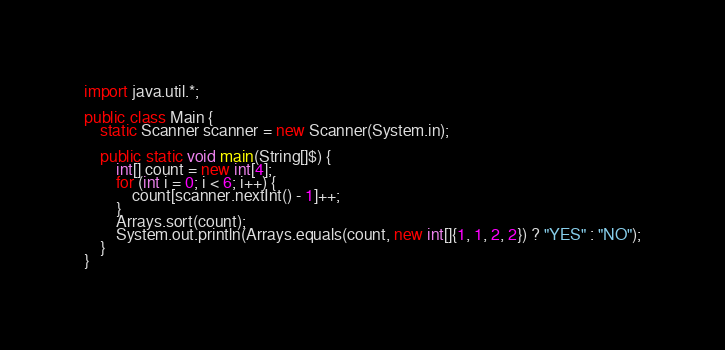Convert code to text. <code><loc_0><loc_0><loc_500><loc_500><_Java_>import java.util.*;

public class Main {
    static Scanner scanner = new Scanner(System.in);

    public static void main(String[]$) {
        int[] count = new int[4];
        for (int i = 0; i < 6; i++) {
            count[scanner.nextInt() - 1]++;
        }
        Arrays.sort(count);
        System.out.println(Arrays.equals(count, new int[]{1, 1, 2, 2}) ? "YES" : "NO");
    }
}</code> 